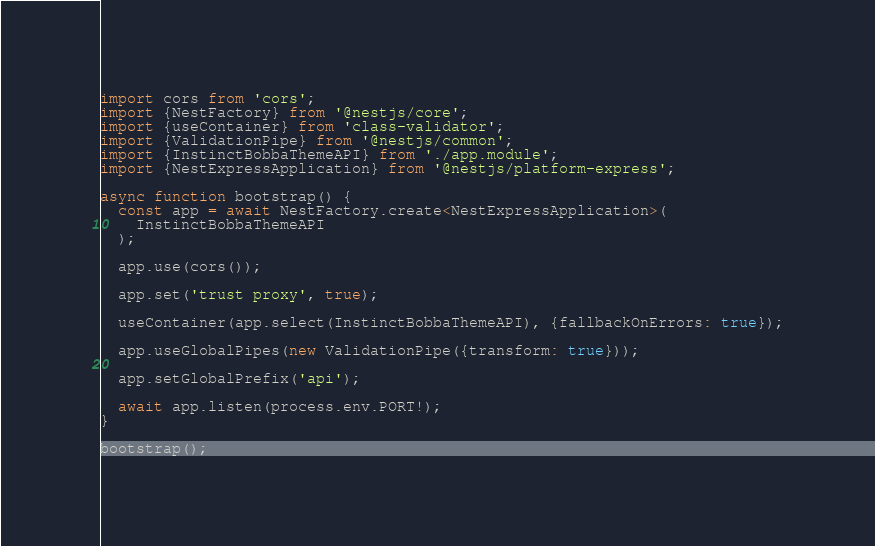<code> <loc_0><loc_0><loc_500><loc_500><_TypeScript_>import cors from 'cors';
import {NestFactory} from '@nestjs/core';
import {useContainer} from 'class-validator';
import {ValidationPipe} from '@nestjs/common';
import {InstinctBobbaThemeAPI} from './app.module';
import {NestExpressApplication} from '@nestjs/platform-express';

async function bootstrap() {
  const app = await NestFactory.create<NestExpressApplication>(
    InstinctBobbaThemeAPI
  );

  app.use(cors());

  app.set('trust proxy', true);

  useContainer(app.select(InstinctBobbaThemeAPI), {fallbackOnErrors: true});

  app.useGlobalPipes(new ValidationPipe({transform: true}));

  app.setGlobalPrefix('api');

  await app.listen(process.env.PORT!);
}

bootstrap();
</code> 